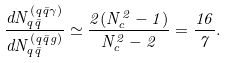<formula> <loc_0><loc_0><loc_500><loc_500>\frac { d N _ { q \bar { q } } ^ { ( q \bar { q } \gamma ) } } { d N _ { q \bar { q } } ^ { ( q \bar { q } g ) } } \simeq \frac { 2 ( N _ { c } ^ { 2 } - 1 ) } { N _ { c } ^ { 2 } - 2 } = \frac { 1 6 } { 7 } .</formula> 